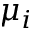Convert formula to latex. <formula><loc_0><loc_0><loc_500><loc_500>\mu _ { i }</formula> 